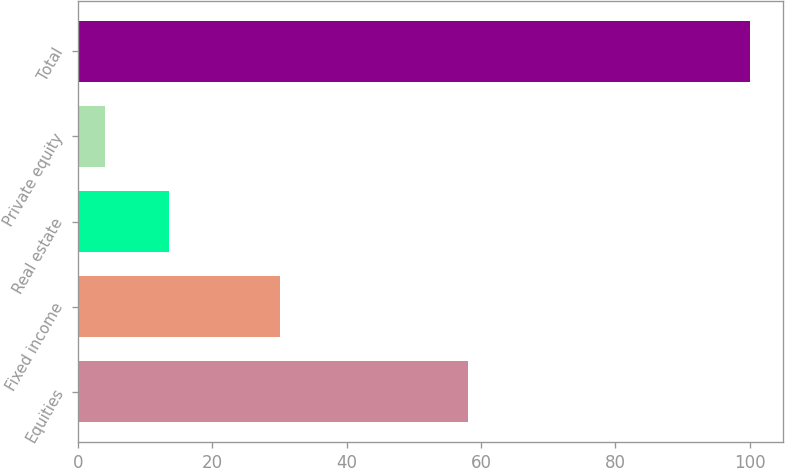<chart> <loc_0><loc_0><loc_500><loc_500><bar_chart><fcel>Equities<fcel>Fixed income<fcel>Real estate<fcel>Private equity<fcel>Total<nl><fcel>58<fcel>30<fcel>13.6<fcel>4<fcel>100<nl></chart> 